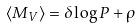Convert formula to latex. <formula><loc_0><loc_0><loc_500><loc_500>\langle M _ { V } \rangle = \delta \log P + \rho</formula> 